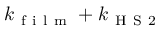Convert formula to latex. <formula><loc_0><loc_0><loc_500><loc_500>k _ { f i l m } + k _ { H S 2 }</formula> 